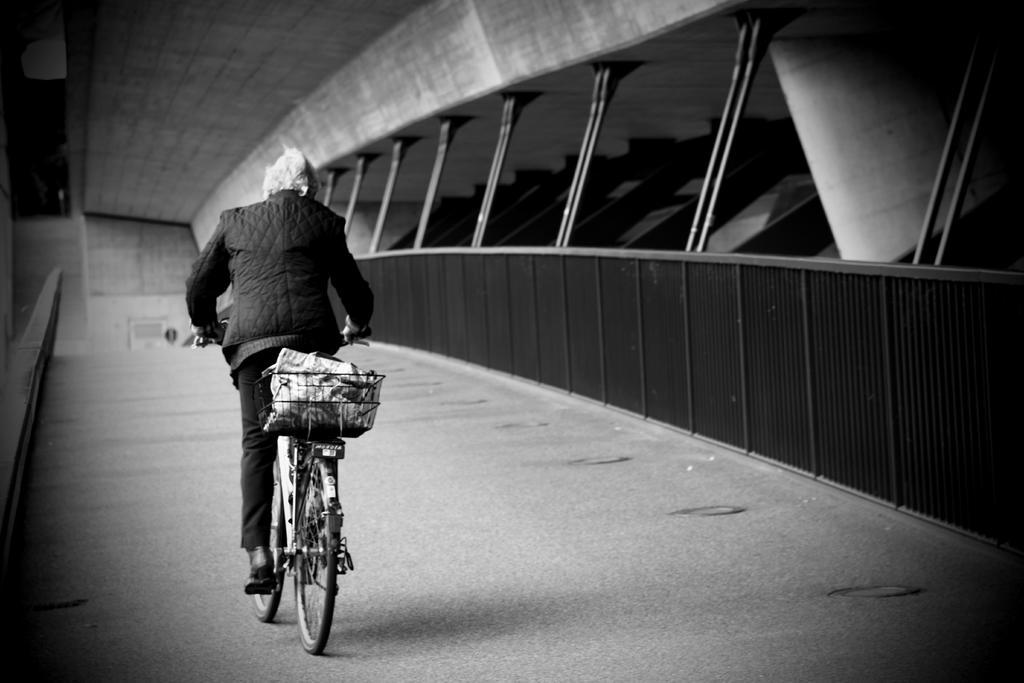What is the person in the image doing? There is a person cycling a bicycle in the image. Where is the person cycling? The person is on a path. What can be seen on the right side of the image? There are windows with glasses on the right side of the image. What is visible in the background of the image? There is a wall in the background of the image. What type of sock is the person wearing while cycling in the image? There is no information about the person's socks in the image, so we cannot determine what type of sock they are wearing. 